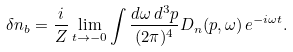Convert formula to latex. <formula><loc_0><loc_0><loc_500><loc_500>\delta n _ { b } = \frac { i } { Z } \lim _ { t \rightarrow - 0 } \int \frac { d \omega \, d ^ { 3 } p } { ( 2 \pi ) ^ { 4 } } D _ { n } ( p , \omega ) \, e ^ { - i \omega t } .</formula> 